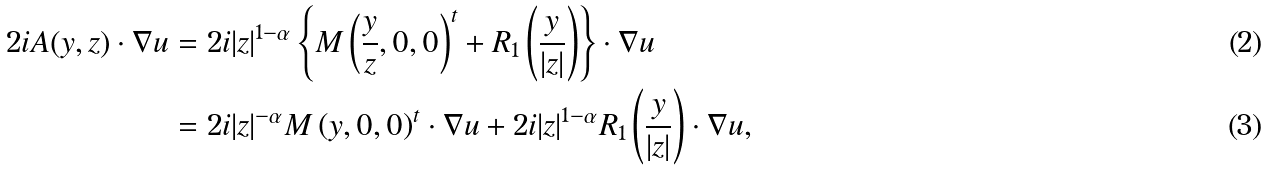<formula> <loc_0><loc_0><loc_500><loc_500>2 i A ( y , z ) \cdot \nabla u & = 2 i | z | ^ { 1 - \alpha } \left \{ M \left ( \frac { y } { z } , 0 , 0 \right ) ^ { t } + R _ { 1 } \left ( \frac { y } { | z | } \right ) \right \} \cdot \nabla u \\ & = 2 i | z | ^ { - \alpha } M \left ( y , 0 , 0 \right ) ^ { t } \cdot \nabla u + 2 i | z | ^ { 1 - \alpha } R _ { 1 } \left ( \frac { y } { | z | } \right ) \cdot \nabla u ,</formula> 